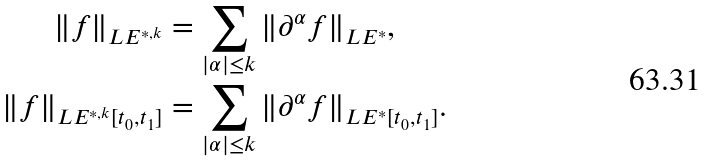<formula> <loc_0><loc_0><loc_500><loc_500>\| f \| _ { L E ^ { * , k } } & = \sum _ { | \alpha | \leq k } \| \partial ^ { \alpha } f \| _ { L E ^ { * } } , \\ \| f \| _ { L E ^ { * , k } [ t _ { 0 } , t _ { 1 } ] } & = \sum _ { | \alpha | \leq k } \| \partial ^ { \alpha } f \| _ { L E ^ { * } [ t _ { 0 } , t _ { 1 } ] } .</formula> 